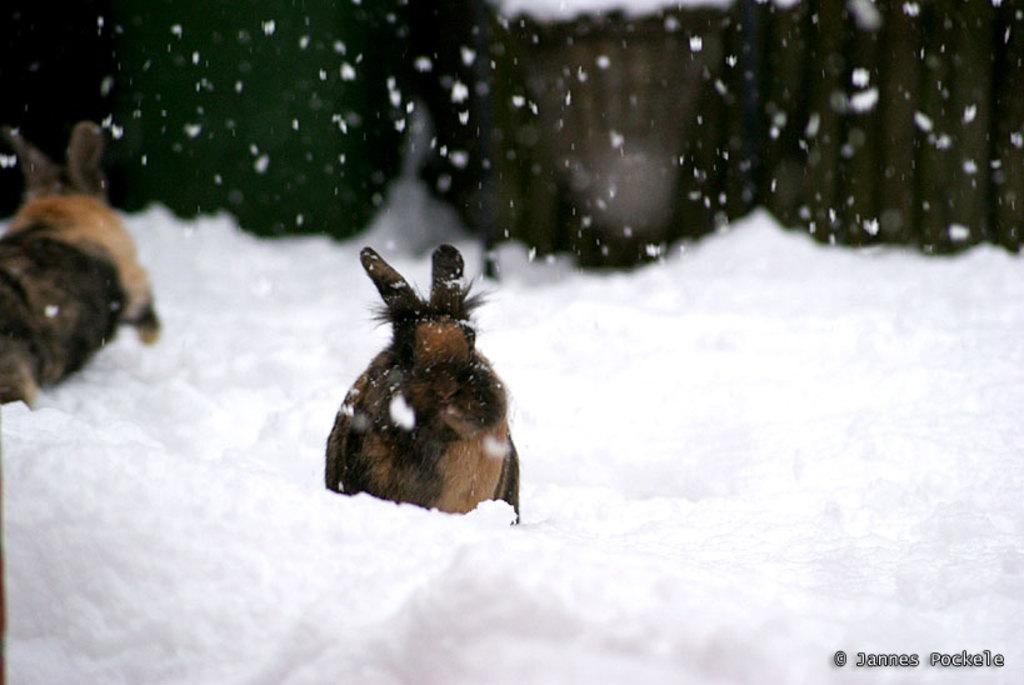How many animals are present in the image? There are two animals in the image. What is the setting in which the animals are located? The animals are on snow. Can you describe the background of the image? The background of the image is blurry. What type of thing is the chin of the animals in the image? There is no chin visible in the image, as it features two animals on snow with a blurry background. 